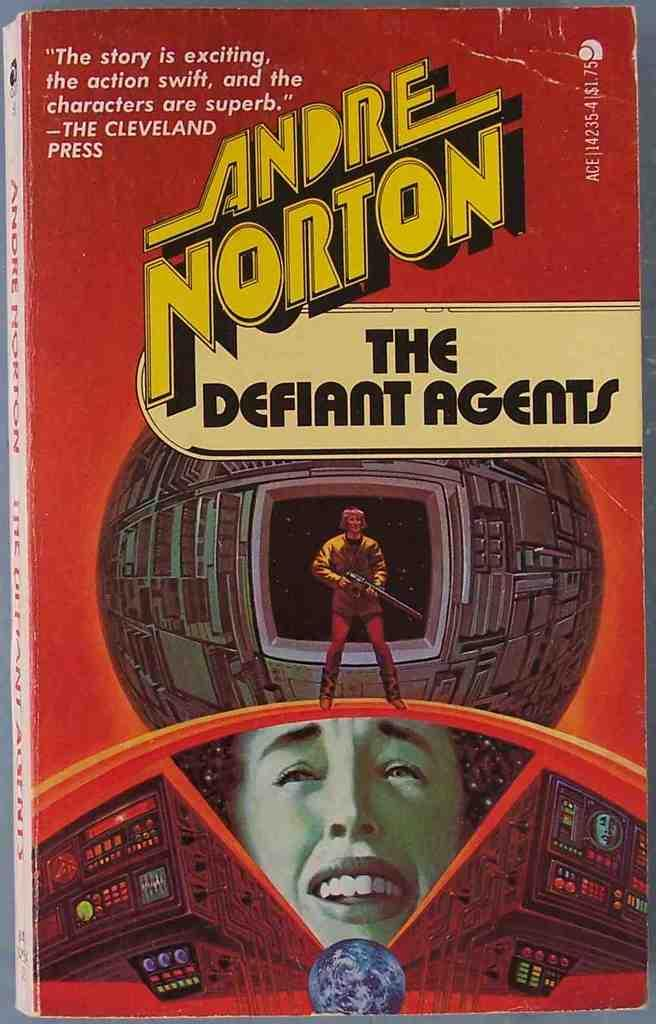<image>
Give a short and clear explanation of the subsequent image. a red and yellow book called The Defiant Agents 